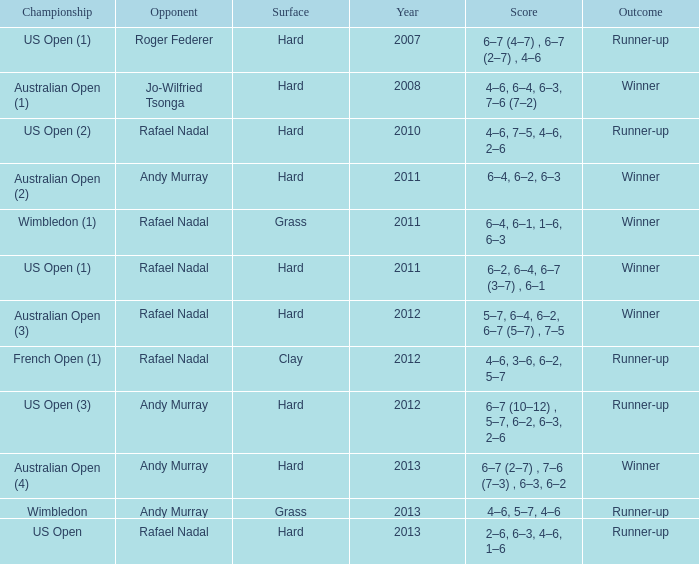What is the outcome of the match with Roger Federer as the opponent? Runner-up. 